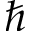Convert formula to latex. <formula><loc_0><loc_0><loc_500><loc_500>\hbar</formula> 